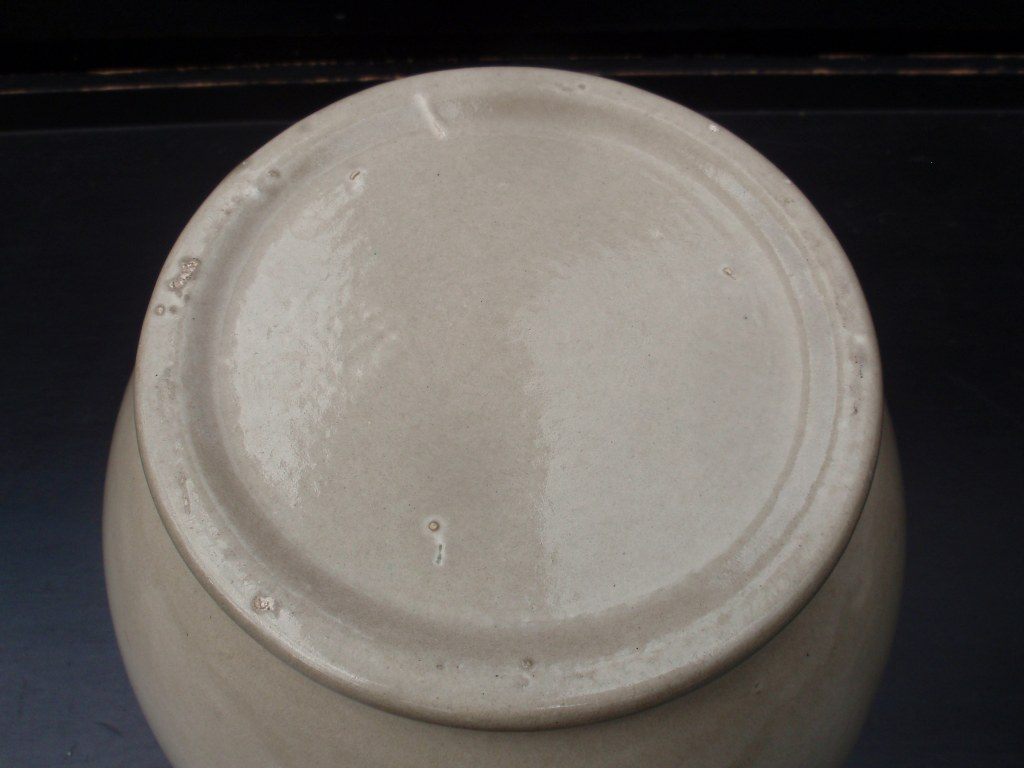What could the size of the object be, based on the perspective and the reflection on the surface? Based on the perspective and the reflection on the surface, it is challenging to determine the exact size of the object precisely. However, the reflection indicates that the object's surface has a slight curvature, which suggests it might be a small to medium-sized item, likely a bowl or a pot. Given that the reflection doesn't stretch extensively from the object's edge, if we assume the surface it rests on is a standard table or countertop, we could estimate the object to be around 15 to 30 centimeters in diameter. This is a speculative estimate and would be more accurate if we had a reference object or measurements in the scene. 